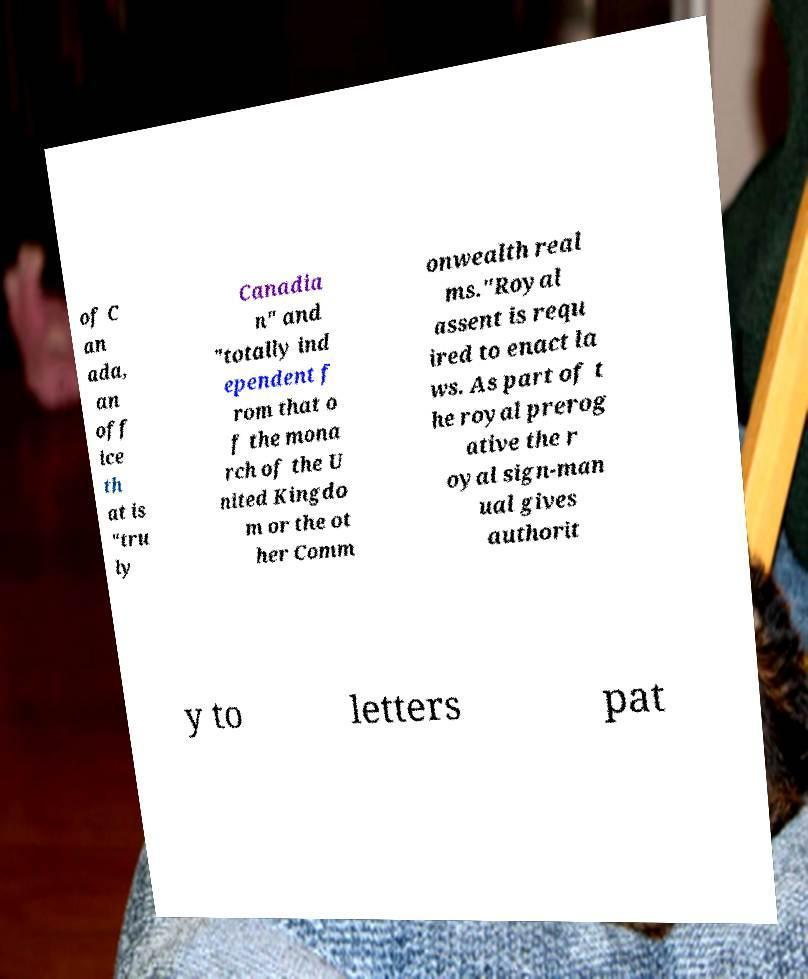Please identify and transcribe the text found in this image. of C an ada, an off ice th at is "tru ly Canadia n" and "totally ind ependent f rom that o f the mona rch of the U nited Kingdo m or the ot her Comm onwealth real ms."Royal assent is requ ired to enact la ws. As part of t he royal prerog ative the r oyal sign-man ual gives authorit y to letters pat 